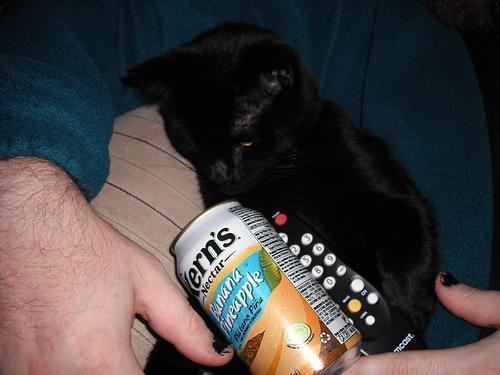How many birds are standing in the water?
Give a very brief answer. 0. 